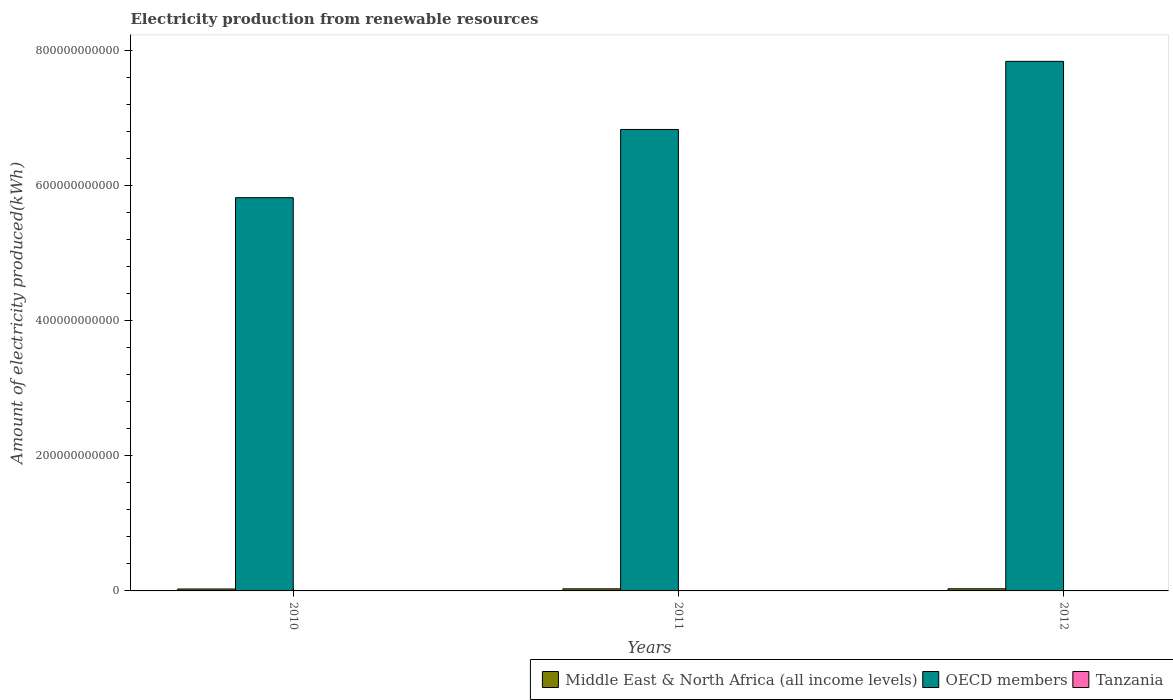How many groups of bars are there?
Make the answer very short. 3. How many bars are there on the 3rd tick from the left?
Offer a terse response. 3. In how many cases, is the number of bars for a given year not equal to the number of legend labels?
Keep it short and to the point. 0. What is the amount of electricity produced in OECD members in 2011?
Offer a terse response. 6.84e+11. Across all years, what is the maximum amount of electricity produced in Tanzania?
Ensure brevity in your answer.  3.20e+07. Across all years, what is the minimum amount of electricity produced in Middle East & North Africa (all income levels)?
Make the answer very short. 2.83e+09. What is the total amount of electricity produced in Middle East & North Africa (all income levels) in the graph?
Keep it short and to the point. 9.09e+09. What is the difference between the amount of electricity produced in Tanzania in 2010 and that in 2012?
Your answer should be very brief. -1.40e+07. What is the difference between the amount of electricity produced in Middle East & North Africa (all income levels) in 2011 and the amount of electricity produced in Tanzania in 2012?
Ensure brevity in your answer.  3.05e+09. What is the average amount of electricity produced in Tanzania per year?
Make the answer very short. 2.50e+07. In the year 2012, what is the difference between the amount of electricity produced in Middle East & North Africa (all income levels) and amount of electricity produced in Tanzania?
Keep it short and to the point. 3.14e+09. In how many years, is the amount of electricity produced in OECD members greater than 280000000000 kWh?
Your answer should be compact. 3. What is the ratio of the amount of electricity produced in Middle East & North Africa (all income levels) in 2010 to that in 2011?
Provide a short and direct response. 0.92. Is the amount of electricity produced in Middle East & North Africa (all income levels) in 2011 less than that in 2012?
Make the answer very short. Yes. What is the difference between the highest and the second highest amount of electricity produced in Middle East & North Africa (all income levels)?
Give a very brief answer. 9.20e+07. What is the difference between the highest and the lowest amount of electricity produced in Tanzania?
Offer a very short reply. 1.40e+07. In how many years, is the amount of electricity produced in Middle East & North Africa (all income levels) greater than the average amount of electricity produced in Middle East & North Africa (all income levels) taken over all years?
Your answer should be compact. 2. What does the 1st bar from the left in 2012 represents?
Make the answer very short. Middle East & North Africa (all income levels). What does the 1st bar from the right in 2012 represents?
Your response must be concise. Tanzania. Is it the case that in every year, the sum of the amount of electricity produced in Middle East & North Africa (all income levels) and amount of electricity produced in OECD members is greater than the amount of electricity produced in Tanzania?
Provide a short and direct response. Yes. Are all the bars in the graph horizontal?
Your response must be concise. No. How many years are there in the graph?
Make the answer very short. 3. What is the difference between two consecutive major ticks on the Y-axis?
Your response must be concise. 2.00e+11. Does the graph contain any zero values?
Ensure brevity in your answer.  No. Where does the legend appear in the graph?
Provide a succinct answer. Bottom right. How many legend labels are there?
Offer a very short reply. 3. How are the legend labels stacked?
Keep it short and to the point. Horizontal. What is the title of the graph?
Offer a terse response. Electricity production from renewable resources. What is the label or title of the Y-axis?
Ensure brevity in your answer.  Amount of electricity produced(kWh). What is the Amount of electricity produced(kWh) of Middle East & North Africa (all income levels) in 2010?
Ensure brevity in your answer.  2.83e+09. What is the Amount of electricity produced(kWh) in OECD members in 2010?
Your answer should be compact. 5.83e+11. What is the Amount of electricity produced(kWh) in Tanzania in 2010?
Your response must be concise. 1.80e+07. What is the Amount of electricity produced(kWh) of Middle East & North Africa (all income levels) in 2011?
Give a very brief answer. 3.08e+09. What is the Amount of electricity produced(kWh) of OECD members in 2011?
Provide a short and direct response. 6.84e+11. What is the Amount of electricity produced(kWh) of Tanzania in 2011?
Your response must be concise. 2.50e+07. What is the Amount of electricity produced(kWh) in Middle East & North Africa (all income levels) in 2012?
Give a very brief answer. 3.18e+09. What is the Amount of electricity produced(kWh) in OECD members in 2012?
Offer a very short reply. 7.85e+11. What is the Amount of electricity produced(kWh) of Tanzania in 2012?
Your answer should be very brief. 3.20e+07. Across all years, what is the maximum Amount of electricity produced(kWh) in Middle East & North Africa (all income levels)?
Your answer should be compact. 3.18e+09. Across all years, what is the maximum Amount of electricity produced(kWh) in OECD members?
Provide a short and direct response. 7.85e+11. Across all years, what is the maximum Amount of electricity produced(kWh) in Tanzania?
Ensure brevity in your answer.  3.20e+07. Across all years, what is the minimum Amount of electricity produced(kWh) of Middle East & North Africa (all income levels)?
Keep it short and to the point. 2.83e+09. Across all years, what is the minimum Amount of electricity produced(kWh) of OECD members?
Offer a terse response. 5.83e+11. Across all years, what is the minimum Amount of electricity produced(kWh) in Tanzania?
Your answer should be compact. 1.80e+07. What is the total Amount of electricity produced(kWh) in Middle East & North Africa (all income levels) in the graph?
Your answer should be very brief. 9.09e+09. What is the total Amount of electricity produced(kWh) of OECD members in the graph?
Give a very brief answer. 2.05e+12. What is the total Amount of electricity produced(kWh) in Tanzania in the graph?
Offer a very short reply. 7.50e+07. What is the difference between the Amount of electricity produced(kWh) in Middle East & North Africa (all income levels) in 2010 and that in 2011?
Your answer should be very brief. -2.57e+08. What is the difference between the Amount of electricity produced(kWh) of OECD members in 2010 and that in 2011?
Offer a very short reply. -1.01e+11. What is the difference between the Amount of electricity produced(kWh) in Tanzania in 2010 and that in 2011?
Ensure brevity in your answer.  -7.00e+06. What is the difference between the Amount of electricity produced(kWh) in Middle East & North Africa (all income levels) in 2010 and that in 2012?
Your answer should be compact. -3.49e+08. What is the difference between the Amount of electricity produced(kWh) in OECD members in 2010 and that in 2012?
Provide a succinct answer. -2.02e+11. What is the difference between the Amount of electricity produced(kWh) in Tanzania in 2010 and that in 2012?
Provide a succinct answer. -1.40e+07. What is the difference between the Amount of electricity produced(kWh) of Middle East & North Africa (all income levels) in 2011 and that in 2012?
Make the answer very short. -9.20e+07. What is the difference between the Amount of electricity produced(kWh) in OECD members in 2011 and that in 2012?
Give a very brief answer. -1.01e+11. What is the difference between the Amount of electricity produced(kWh) in Tanzania in 2011 and that in 2012?
Give a very brief answer. -7.00e+06. What is the difference between the Amount of electricity produced(kWh) of Middle East & North Africa (all income levels) in 2010 and the Amount of electricity produced(kWh) of OECD members in 2011?
Offer a very short reply. -6.81e+11. What is the difference between the Amount of electricity produced(kWh) of Middle East & North Africa (all income levels) in 2010 and the Amount of electricity produced(kWh) of Tanzania in 2011?
Give a very brief answer. 2.80e+09. What is the difference between the Amount of electricity produced(kWh) of OECD members in 2010 and the Amount of electricity produced(kWh) of Tanzania in 2011?
Keep it short and to the point. 5.83e+11. What is the difference between the Amount of electricity produced(kWh) in Middle East & North Africa (all income levels) in 2010 and the Amount of electricity produced(kWh) in OECD members in 2012?
Offer a terse response. -7.82e+11. What is the difference between the Amount of electricity produced(kWh) in Middle East & North Africa (all income levels) in 2010 and the Amount of electricity produced(kWh) in Tanzania in 2012?
Offer a terse response. 2.80e+09. What is the difference between the Amount of electricity produced(kWh) in OECD members in 2010 and the Amount of electricity produced(kWh) in Tanzania in 2012?
Keep it short and to the point. 5.83e+11. What is the difference between the Amount of electricity produced(kWh) in Middle East & North Africa (all income levels) in 2011 and the Amount of electricity produced(kWh) in OECD members in 2012?
Your response must be concise. -7.81e+11. What is the difference between the Amount of electricity produced(kWh) in Middle East & North Africa (all income levels) in 2011 and the Amount of electricity produced(kWh) in Tanzania in 2012?
Your answer should be very brief. 3.05e+09. What is the difference between the Amount of electricity produced(kWh) in OECD members in 2011 and the Amount of electricity produced(kWh) in Tanzania in 2012?
Offer a terse response. 6.84e+11. What is the average Amount of electricity produced(kWh) in Middle East & North Africa (all income levels) per year?
Give a very brief answer. 3.03e+09. What is the average Amount of electricity produced(kWh) of OECD members per year?
Provide a succinct answer. 6.84e+11. What is the average Amount of electricity produced(kWh) of Tanzania per year?
Your answer should be compact. 2.50e+07. In the year 2010, what is the difference between the Amount of electricity produced(kWh) of Middle East & North Africa (all income levels) and Amount of electricity produced(kWh) of OECD members?
Make the answer very short. -5.80e+11. In the year 2010, what is the difference between the Amount of electricity produced(kWh) of Middle East & North Africa (all income levels) and Amount of electricity produced(kWh) of Tanzania?
Keep it short and to the point. 2.81e+09. In the year 2010, what is the difference between the Amount of electricity produced(kWh) in OECD members and Amount of electricity produced(kWh) in Tanzania?
Your answer should be compact. 5.83e+11. In the year 2011, what is the difference between the Amount of electricity produced(kWh) in Middle East & North Africa (all income levels) and Amount of electricity produced(kWh) in OECD members?
Offer a very short reply. -6.81e+11. In the year 2011, what is the difference between the Amount of electricity produced(kWh) in Middle East & North Africa (all income levels) and Amount of electricity produced(kWh) in Tanzania?
Ensure brevity in your answer.  3.06e+09. In the year 2011, what is the difference between the Amount of electricity produced(kWh) of OECD members and Amount of electricity produced(kWh) of Tanzania?
Provide a succinct answer. 6.84e+11. In the year 2012, what is the difference between the Amount of electricity produced(kWh) in Middle East & North Africa (all income levels) and Amount of electricity produced(kWh) in OECD members?
Make the answer very short. -7.81e+11. In the year 2012, what is the difference between the Amount of electricity produced(kWh) in Middle East & North Africa (all income levels) and Amount of electricity produced(kWh) in Tanzania?
Your answer should be compact. 3.14e+09. In the year 2012, what is the difference between the Amount of electricity produced(kWh) in OECD members and Amount of electricity produced(kWh) in Tanzania?
Your response must be concise. 7.84e+11. What is the ratio of the Amount of electricity produced(kWh) of Middle East & North Africa (all income levels) in 2010 to that in 2011?
Ensure brevity in your answer.  0.92. What is the ratio of the Amount of electricity produced(kWh) in OECD members in 2010 to that in 2011?
Provide a short and direct response. 0.85. What is the ratio of the Amount of electricity produced(kWh) of Tanzania in 2010 to that in 2011?
Provide a succinct answer. 0.72. What is the ratio of the Amount of electricity produced(kWh) in Middle East & North Africa (all income levels) in 2010 to that in 2012?
Keep it short and to the point. 0.89. What is the ratio of the Amount of electricity produced(kWh) in OECD members in 2010 to that in 2012?
Make the answer very short. 0.74. What is the ratio of the Amount of electricity produced(kWh) in Tanzania in 2010 to that in 2012?
Make the answer very short. 0.56. What is the ratio of the Amount of electricity produced(kWh) in Middle East & North Africa (all income levels) in 2011 to that in 2012?
Your answer should be very brief. 0.97. What is the ratio of the Amount of electricity produced(kWh) of OECD members in 2011 to that in 2012?
Ensure brevity in your answer.  0.87. What is the ratio of the Amount of electricity produced(kWh) of Tanzania in 2011 to that in 2012?
Offer a very short reply. 0.78. What is the difference between the highest and the second highest Amount of electricity produced(kWh) of Middle East & North Africa (all income levels)?
Keep it short and to the point. 9.20e+07. What is the difference between the highest and the second highest Amount of electricity produced(kWh) in OECD members?
Your answer should be compact. 1.01e+11. What is the difference between the highest and the second highest Amount of electricity produced(kWh) in Tanzania?
Your answer should be very brief. 7.00e+06. What is the difference between the highest and the lowest Amount of electricity produced(kWh) in Middle East & North Africa (all income levels)?
Offer a terse response. 3.49e+08. What is the difference between the highest and the lowest Amount of electricity produced(kWh) of OECD members?
Your answer should be compact. 2.02e+11. What is the difference between the highest and the lowest Amount of electricity produced(kWh) of Tanzania?
Provide a short and direct response. 1.40e+07. 